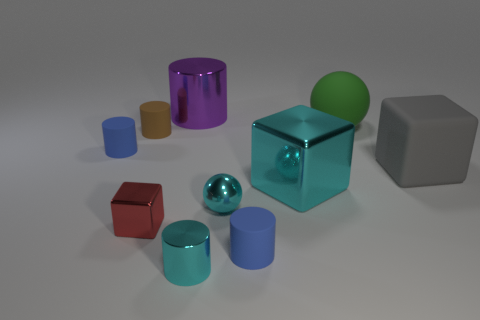Subtract all purple cylinders. How many cylinders are left? 4 Subtract 2 cylinders. How many cylinders are left? 3 Subtract all cubes. How many objects are left? 7 Subtract all large metal cylinders. Subtract all small red blocks. How many objects are left? 8 Add 5 green spheres. How many green spheres are left? 6 Add 6 red metal objects. How many red metal objects exist? 7 Subtract 0 blue blocks. How many objects are left? 10 